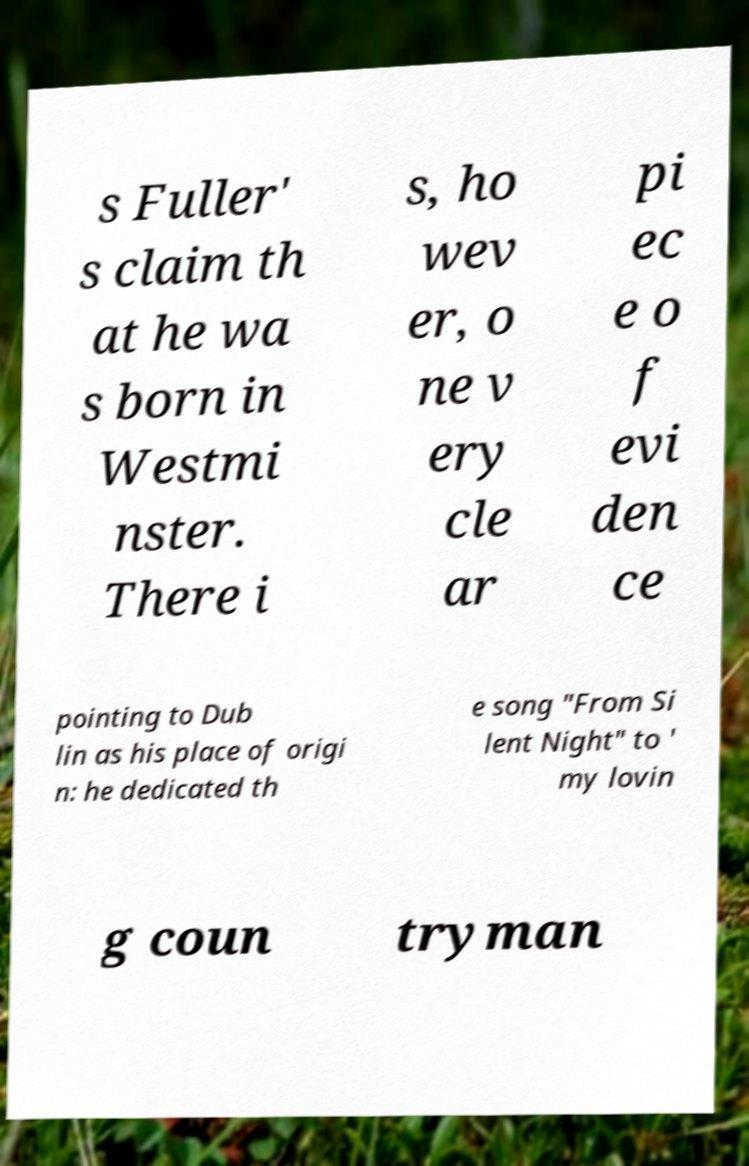Please identify and transcribe the text found in this image. s Fuller' s claim th at he wa s born in Westmi nster. There i s, ho wev er, o ne v ery cle ar pi ec e o f evi den ce pointing to Dub lin as his place of origi n: he dedicated th e song "From Si lent Night" to ' my lovin g coun tryman 